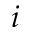<formula> <loc_0><loc_0><loc_500><loc_500>i</formula> 